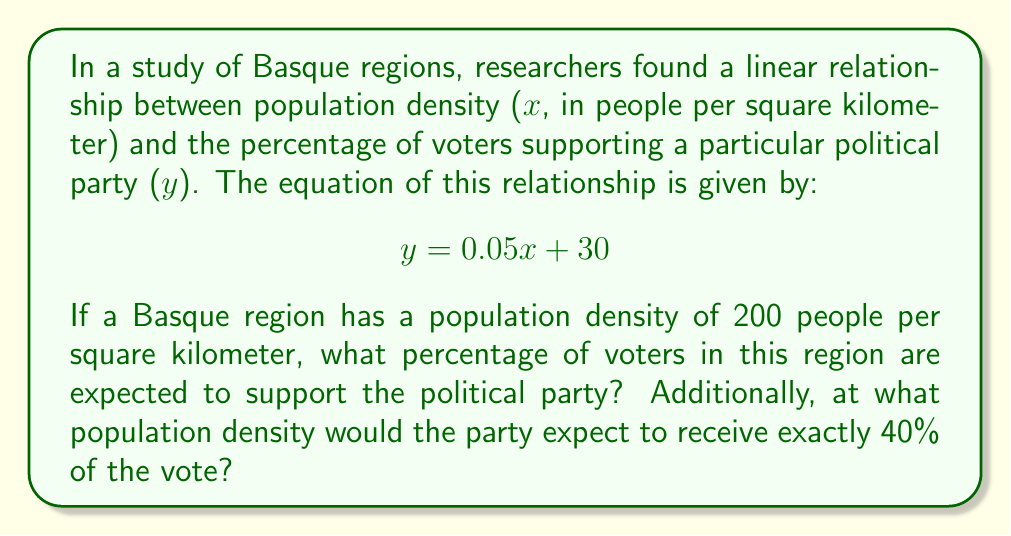Help me with this question. To solve this problem, we'll use the given linear equation:

$$ y = 0.05x + 30 $$

Where:
$x$ = population density (people per square kilometer)
$y$ = percentage of voters supporting the political party

1. To find the percentage of voters supporting the party in a region with 200 people per square kilometer:
   Substitute $x = 200$ into the equation:
   $$ y = 0.05(200) + 30 $$
   $$ y = 10 + 30 = 40 $$
   
   Therefore, in a region with a population density of 200 people per square kilometer, 40% of voters are expected to support the party.

2. To find the population density where the party receives exactly 40% of the vote:
   Set $y = 40$ and solve for $x$:
   $$ 40 = 0.05x + 30 $$
   $$ 10 = 0.05x $$
   $$ x = 10 / 0.05 = 200 $$

   This confirms our previous calculation and shows that at a population density of 200 people per square kilometer, the party would receive exactly 40% of the vote.
Answer: 1. In a Basque region with a population density of 200 people per square kilometer, 40% of voters are expected to support the political party.
2. The party would receive exactly 40% of the vote at a population density of 200 people per square kilometer. 